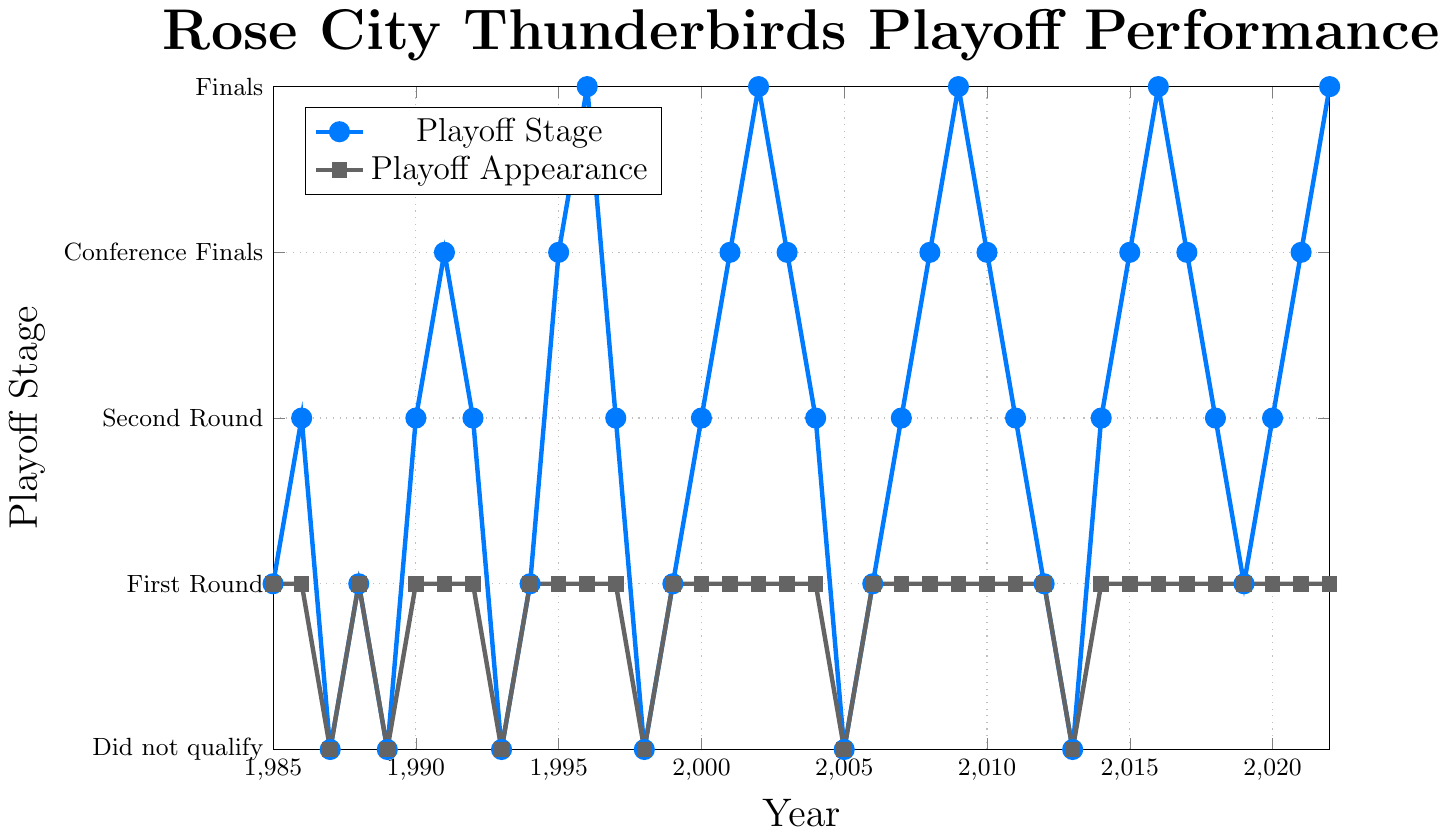what year did the Rose City Thunderbirds first advance to the Finals stage? Look for the year where the advancement stage reaches 4, which indicates the Finals stage. The first occurrence is in 1996.
Answer: 1996 How many times did the Rose City Thunderbirds miss the playoffs between 1985 and 2022? Identify years where the playoff stage is 0. Counting these occurrences for the given period results in 8 years where they missed the playoffs.
Answer: 8 Compare the playoff advancement stage in 1991 and 2022. Which year had a higher stage, and by how much? In 1991, the advancement stage was 3 (Conference Finals). In 2022, it was 4 (Finals). The difference between the two stages is 1.
Answer: 2022, by 1 stage What is the most frequent playoff advancement stage for the Rose City Thunderbirds from 1985 to 2022? Count the occurrences of each playoff stage (0, 1, 2, 3, 4) from the data. The most frequent stage is 1, which corresponds to the First Round.
Answer: 1 (First Round) How many times did the Rose City Thunderbirds advance to the Conference Finals stage (stage 3) between 2000 and 2022? Look for occurrences of the number 3 in the advancement stage from 2000 to 2022. The team reached the Conference Finals 5 times (2001, 2003, 2008, 2010, 2017).
Answer: 5 How many consecutive years did the Rose City Thunderbirds make playoff appearances starting from 2006? Check yearly data starting from 2006 and find the number of consecutive years with playoff appearances until a break. They appeared continuously from 2006 to 2022, which sums up to 17 years.
Answer: 17 years Which year had the same playoff advancement stage as 2012 but did not qualify for the playoffs in at least one previous year? In 2012, the stage was 1. The first occurrence matching stage 1 after missing playoffs previously is 2006 (they missed in 2005).
Answer: 2006 What is the overall trend in the playoff advancement stage from the period of 2008 to 2016? Visually interpret the graph to identify an upward or downward trend. The trend shows increasing advancement (2008: 3, 2009: 4, 2010: 3, 2011: 2, 2012: 1, 2013: 0, 2014: 2, 2015: 3, 2016: 4). Generally upward despite minor fluctuations.
Answer: Upward trend In which years did the Rose City Thunderbirds reach beyond the Conference Finals stage but not in consecutive years? Identify the years with the stage of 4 (Finals) that are not consecutive. The years 1996, 2002, 2009, and 2016 qualify as they are not all consecutive.
Answer: 1996, 2002, 2009, 2016 